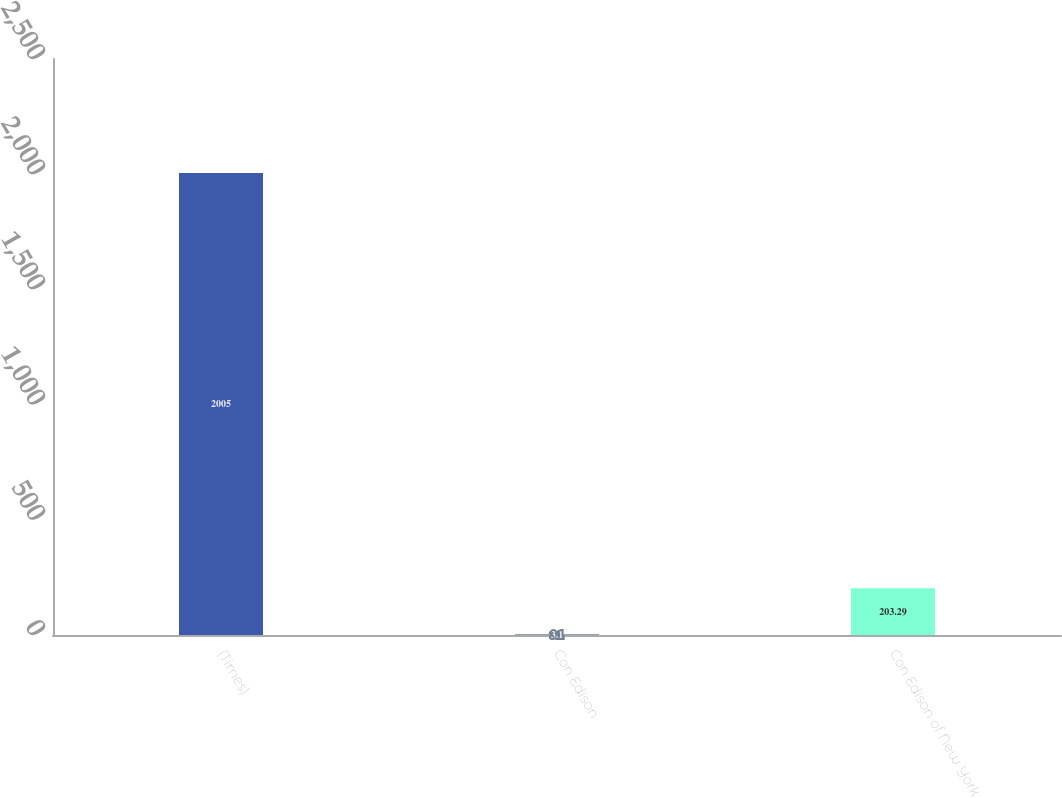Convert chart. <chart><loc_0><loc_0><loc_500><loc_500><bar_chart><fcel>(Times)<fcel>Con Edison<fcel>Con Edison of New York<nl><fcel>2005<fcel>3.1<fcel>203.29<nl></chart> 